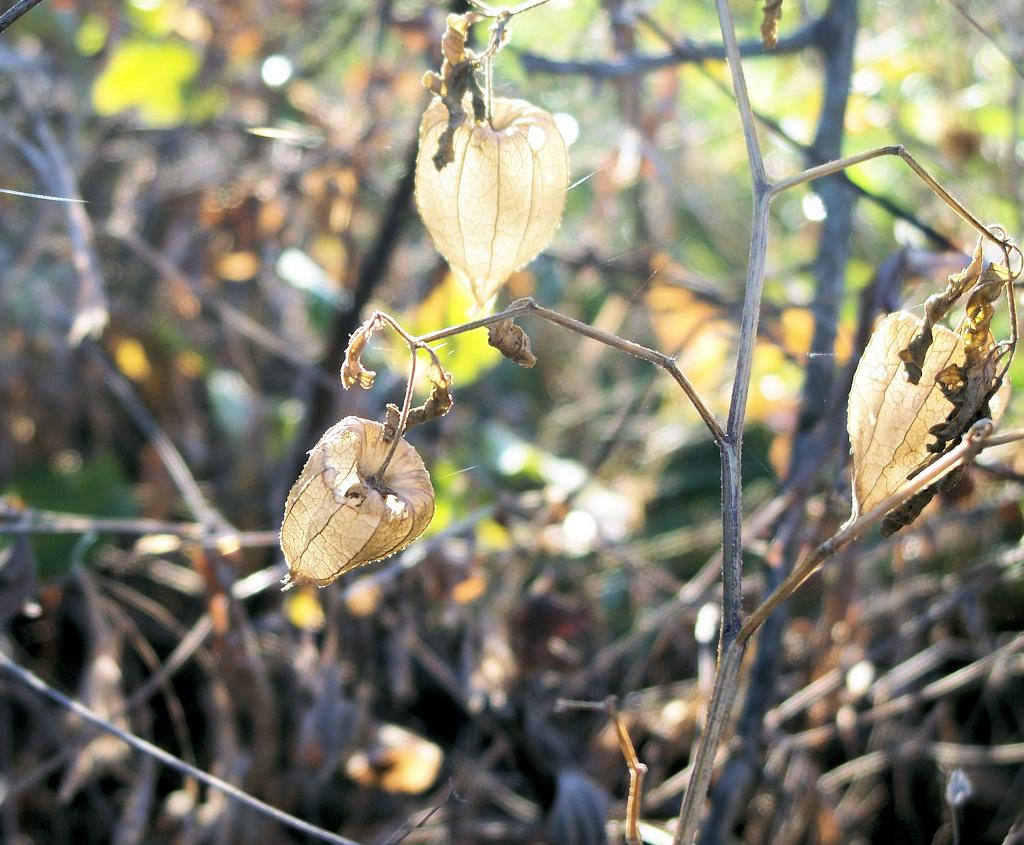What type of plants are in the image? There are dried plants in the image. What else can be seen in the image besides the dried plants? There are dried leaves in the image. What type of fog can be seen in the image? There is no fog present in the image; it features dried plants and leaves. What type of activity is taking place in the image? The image does not depict any specific activity; it simply shows dried plants and leaves. 